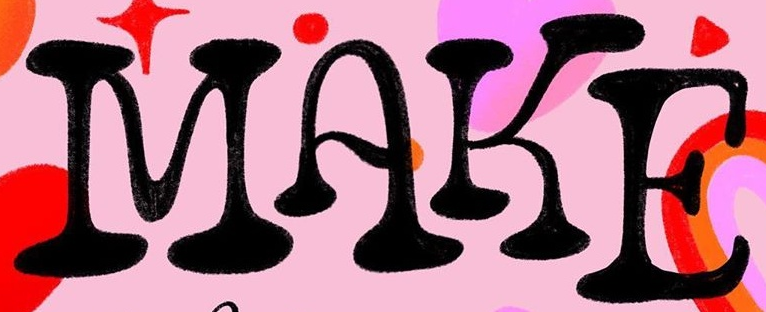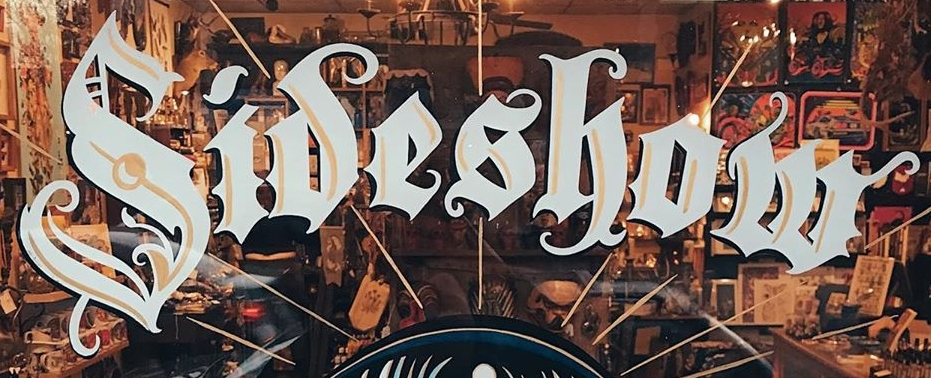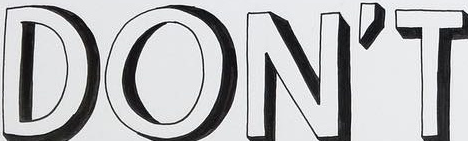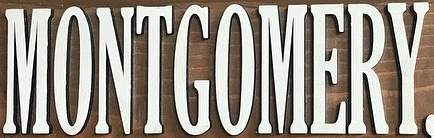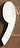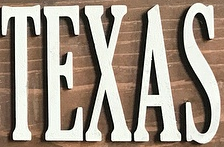What text is displayed in these images sequentially, separated by a semicolon? MAKE; Sideshow; DON'T; MONTGOMERY; ,; TEXAS 